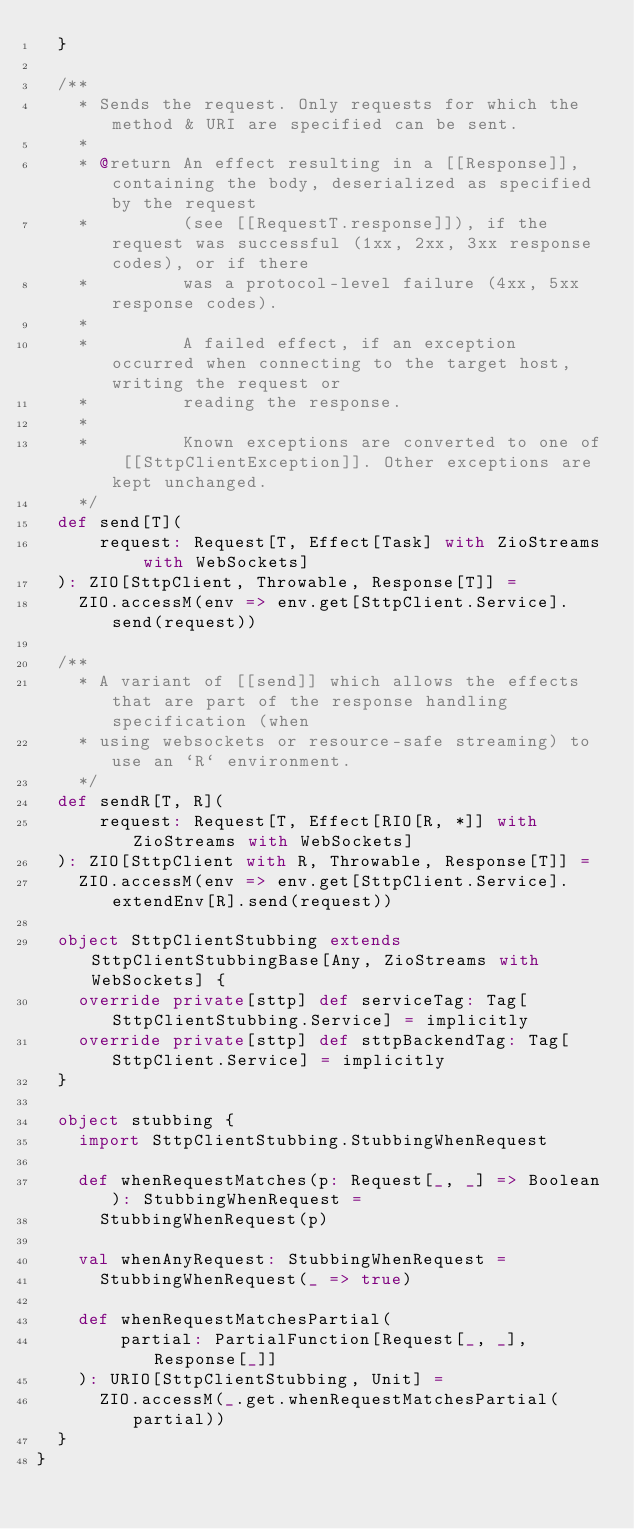Convert code to text. <code><loc_0><loc_0><loc_500><loc_500><_Scala_>  }

  /**
    * Sends the request. Only requests for which the method & URI are specified can be sent.
    *
    * @return An effect resulting in a [[Response]], containing the body, deserialized as specified by the request
    *         (see [[RequestT.response]]), if the request was successful (1xx, 2xx, 3xx response codes), or if there
    *         was a protocol-level failure (4xx, 5xx response codes).
    *
    *         A failed effect, if an exception occurred when connecting to the target host, writing the request or
    *         reading the response.
    *
    *         Known exceptions are converted to one of [[SttpClientException]]. Other exceptions are kept unchanged.
    */
  def send[T](
      request: Request[T, Effect[Task] with ZioStreams with WebSockets]
  ): ZIO[SttpClient, Throwable, Response[T]] =
    ZIO.accessM(env => env.get[SttpClient.Service].send(request))

  /**
    * A variant of [[send]] which allows the effects that are part of the response handling specification (when
    * using websockets or resource-safe streaming) to use an `R` environment.
    */
  def sendR[T, R](
      request: Request[T, Effect[RIO[R, *]] with ZioStreams with WebSockets]
  ): ZIO[SttpClient with R, Throwable, Response[T]] =
    ZIO.accessM(env => env.get[SttpClient.Service].extendEnv[R].send(request))

  object SttpClientStubbing extends SttpClientStubbingBase[Any, ZioStreams with WebSockets] {
    override private[sttp] def serviceTag: Tag[SttpClientStubbing.Service] = implicitly
    override private[sttp] def sttpBackendTag: Tag[SttpClient.Service] = implicitly
  }

  object stubbing {
    import SttpClientStubbing.StubbingWhenRequest

    def whenRequestMatches(p: Request[_, _] => Boolean): StubbingWhenRequest =
      StubbingWhenRequest(p)

    val whenAnyRequest: StubbingWhenRequest =
      StubbingWhenRequest(_ => true)

    def whenRequestMatchesPartial(
        partial: PartialFunction[Request[_, _], Response[_]]
    ): URIO[SttpClientStubbing, Unit] =
      ZIO.accessM(_.get.whenRequestMatchesPartial(partial))
  }
}
</code> 